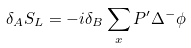Convert formula to latex. <formula><loc_0><loc_0><loc_500><loc_500>\delta _ { A } S _ { L } = - i \delta _ { B } \sum _ { x } P ^ { \prime } \Delta ^ { - } \phi</formula> 